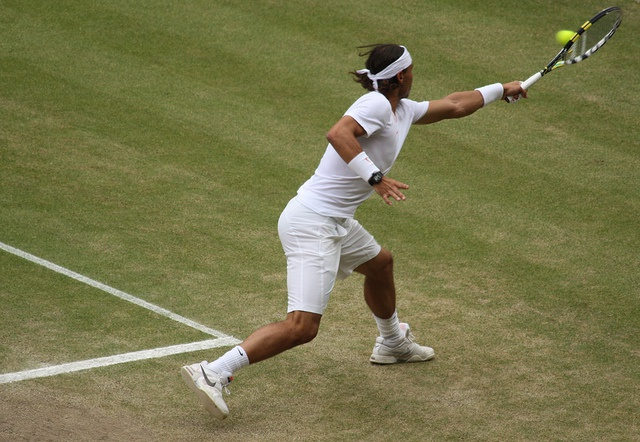Describe the objects in this image and their specific colors. I can see people in olive, lavender, darkgray, black, and gray tones, tennis racket in olive, darkgreen, gray, black, and darkgray tones, and sports ball in olive, yellow, and khaki tones in this image. 